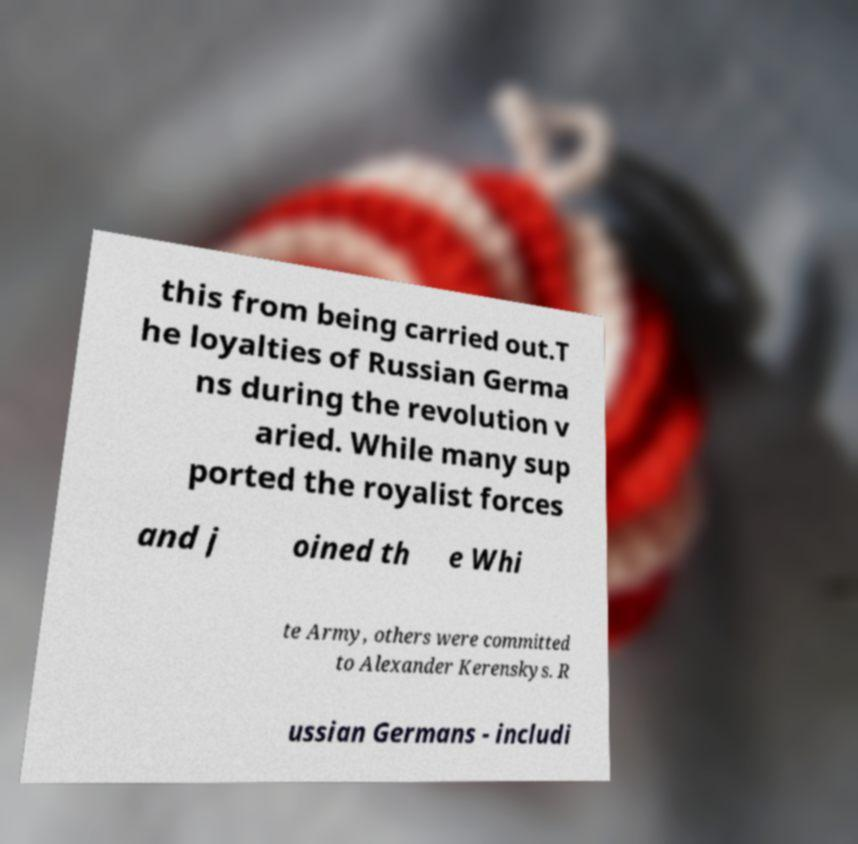Could you assist in decoding the text presented in this image and type it out clearly? this from being carried out.T he loyalties of Russian Germa ns during the revolution v aried. While many sup ported the royalist forces and j oined th e Whi te Army, others were committed to Alexander Kerenskys. R ussian Germans - includi 